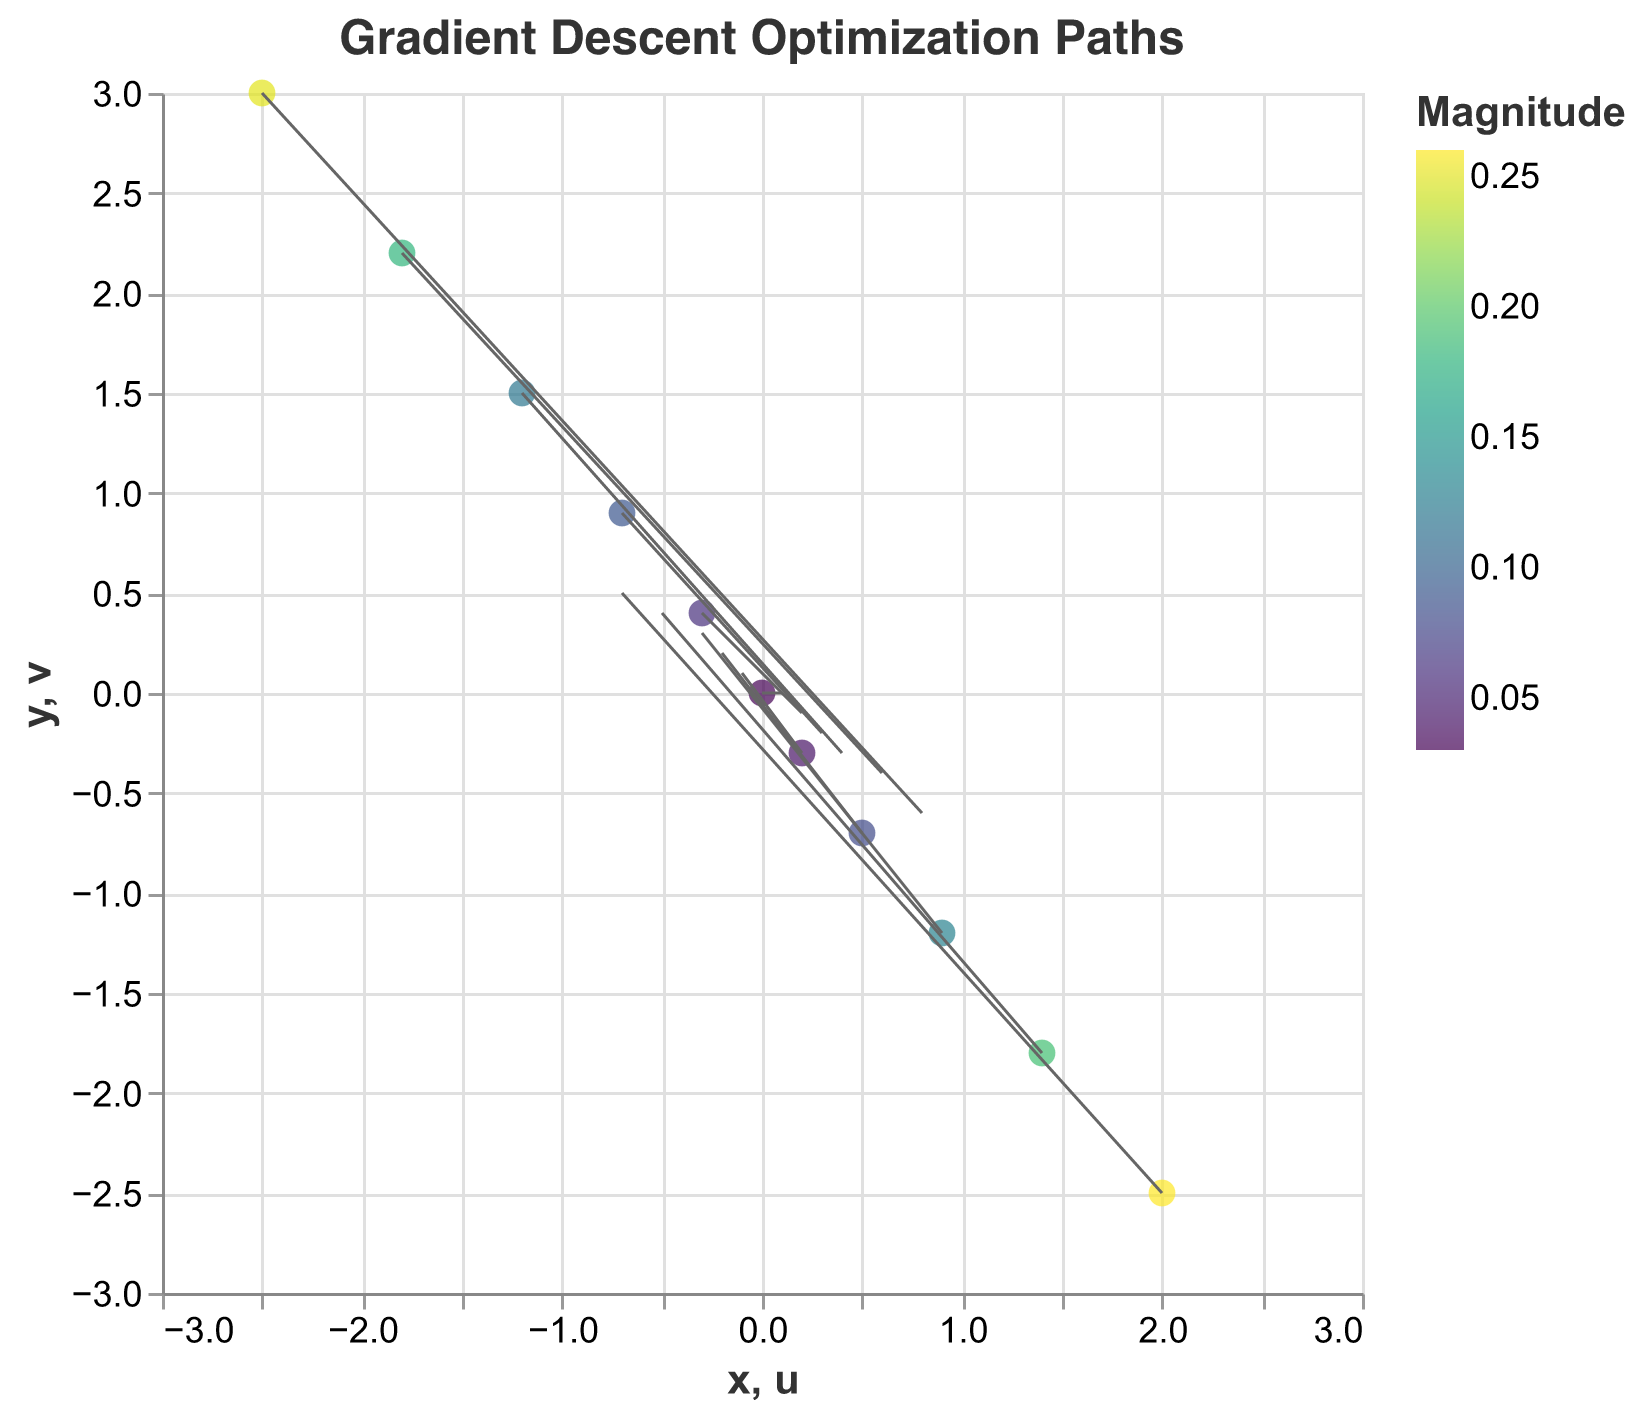What's the title of the plot? The title of the plot is at the top center and is written in a larger font size compared to other text elements. In this plot, it is "Gradient Descent Optimization Paths".
Answer: Gradient Descent Optimization Paths What are the x and y axis ranges? The scales for both x and y axes are given as domains in the code. The range for both x and y axes is from -3 to 3.
Answer: -3 to 3 How many data points are in the plot? You can count the pairs of x and y coordinates provided in the dataset. There are 11 such pairs.
Answer: 11 What is the color scheme used to indicate magnitude? The color scheme is specified as "viridis" in the encoding for color.
Answer: viridis Which data point has the highest magnitude, and what is its value? The magnitudes are indicated in the dataset provided. The highest value is 0.26, which corresponds to the data point at (2.0, -2.5).
Answer: (2.0, -2.5), 0.26 What does the direction of the arrow represent in this plot? In a quiver plot, the direction of the arrow represents the direction of the gradient descent step at each point. The u and v components indicate the horizontal and vertical components of this step.
Answer: Direction of gradient descent step Which data point has the smallest magnitude, and what is its value? The magnitudes are listed in the dataset. The smallest value is 0.03, corresponding to the data point at (0.0, 0.0).
Answer: (0.0, 0.0), 0.03 Compare the magnitudes of the data points at (1.4, -1.8) and (0.9, -1.2). Which one is greater? By checking the magnitudes for the given data points, we see that the magnitude for (1.4, -1.8) is 0.19, and for (0.9, -1.2), it is 0.13. Hence, 0.19 is greater than 0.13.
Answer: The magnitude at (1.4, -1.8) is greater What is the magnitude color for the data point at (-0.3, 0.4)? The color scheme "viridis" is used to indicate magnitude. The magnitude value for this data point is 0.06, which would correspond to a specific color in the "viridis" scale.
Answer: Color corresponding to 0.06 in "viridis" scale What pattern can you observe in the direction and length of the arrows as you move from negative to positive x-values? According to the data, moving from left to right, the arrows change direction and become shorter until (0.0, 0.0), after which they reverse direction and increase in length reflecting the gradient steps.
Answer: Arrows shorten, change direction, then lengthen 